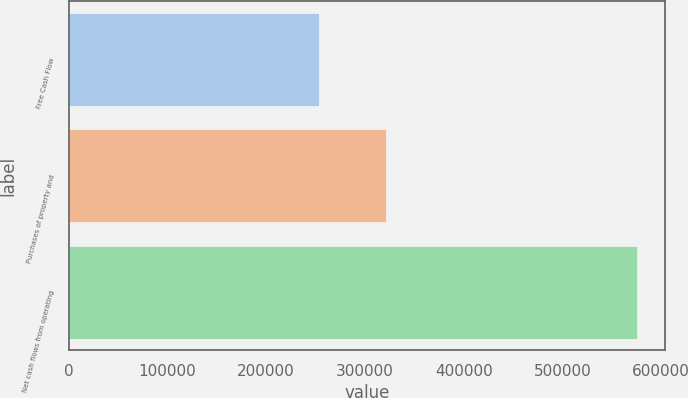Convert chart. <chart><loc_0><loc_0><loc_500><loc_500><bar_chart><fcel>Free Cash Flow<fcel>Purchases of property and<fcel>Net cash flows from operating<nl><fcel>253762<fcel>321819<fcel>575581<nl></chart> 